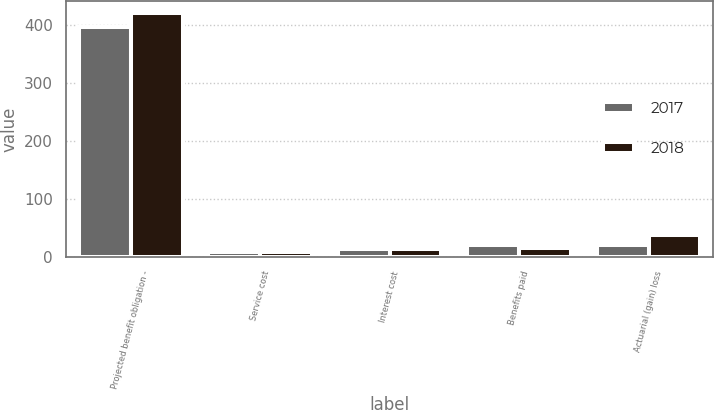<chart> <loc_0><loc_0><loc_500><loc_500><stacked_bar_chart><ecel><fcel>Projected benefit obligation -<fcel>Service cost<fcel>Interest cost<fcel>Benefits paid<fcel>Actuarial (gain) loss<nl><fcel>2017<fcel>396<fcel>8<fcel>14.2<fcel>20.3<fcel>21.1<nl><fcel>2018<fcel>420.7<fcel>8.7<fcel>14<fcel>14.9<fcel>36.9<nl></chart> 